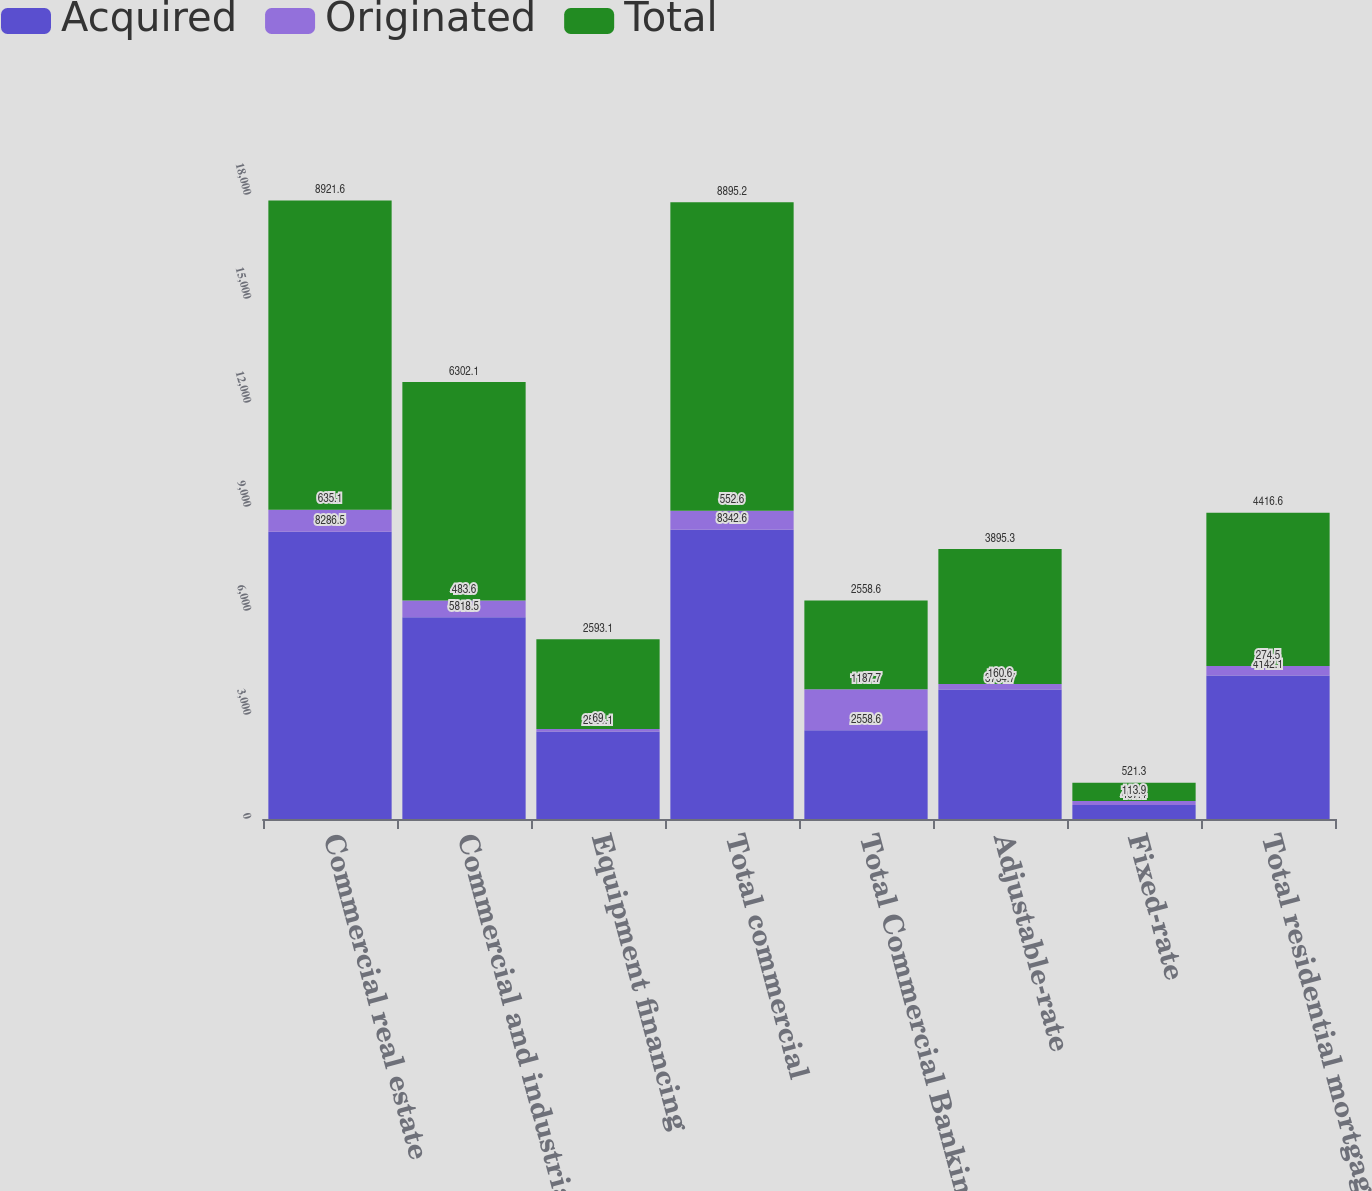Convert chart. <chart><loc_0><loc_0><loc_500><loc_500><stacked_bar_chart><ecel><fcel>Commercial real estate<fcel>Commercial and industrial<fcel>Equipment financing<fcel>Total commercial<fcel>Total Commercial Banking<fcel>Adjustable-rate<fcel>Fixed-rate<fcel>Total residential mortgage<nl><fcel>Acquired<fcel>8286.5<fcel>5818.5<fcel>2524.1<fcel>8342.6<fcel>2558.6<fcel>3734.7<fcel>407.4<fcel>4142.1<nl><fcel>Originated<fcel>635.1<fcel>483.6<fcel>69<fcel>552.6<fcel>1187.7<fcel>160.6<fcel>113.9<fcel>274.5<nl><fcel>Total<fcel>8921.6<fcel>6302.1<fcel>2593.1<fcel>8895.2<fcel>2558.6<fcel>3895.3<fcel>521.3<fcel>4416.6<nl></chart> 